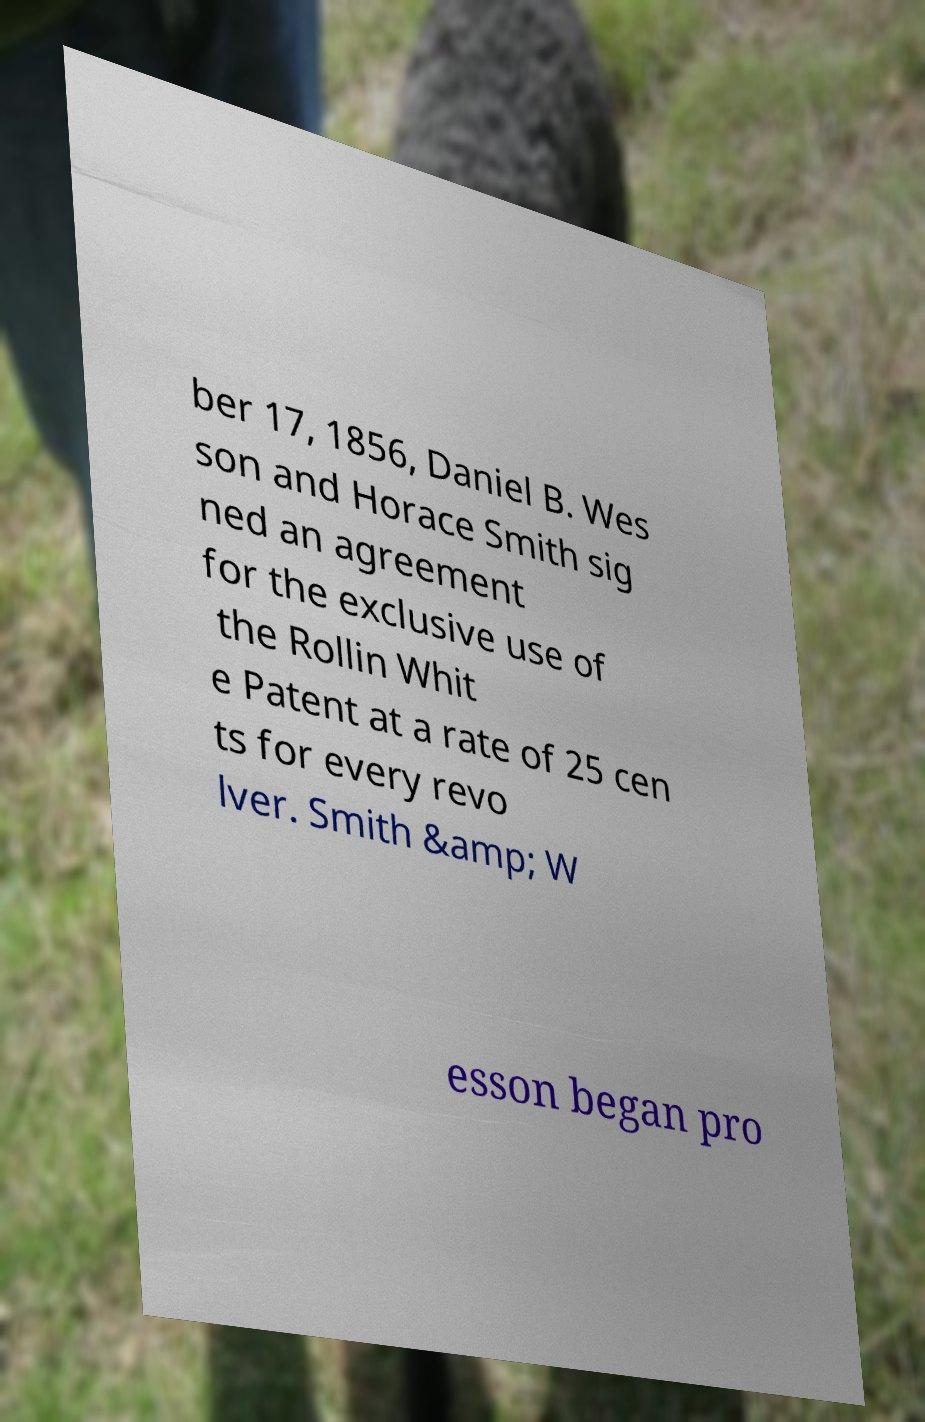Can you read and provide the text displayed in the image?This photo seems to have some interesting text. Can you extract and type it out for me? ber 17, 1856, Daniel B. Wes son and Horace Smith sig ned an agreement for the exclusive use of the Rollin Whit e Patent at a rate of 25 cen ts for every revo lver. Smith &amp; W esson began pro 